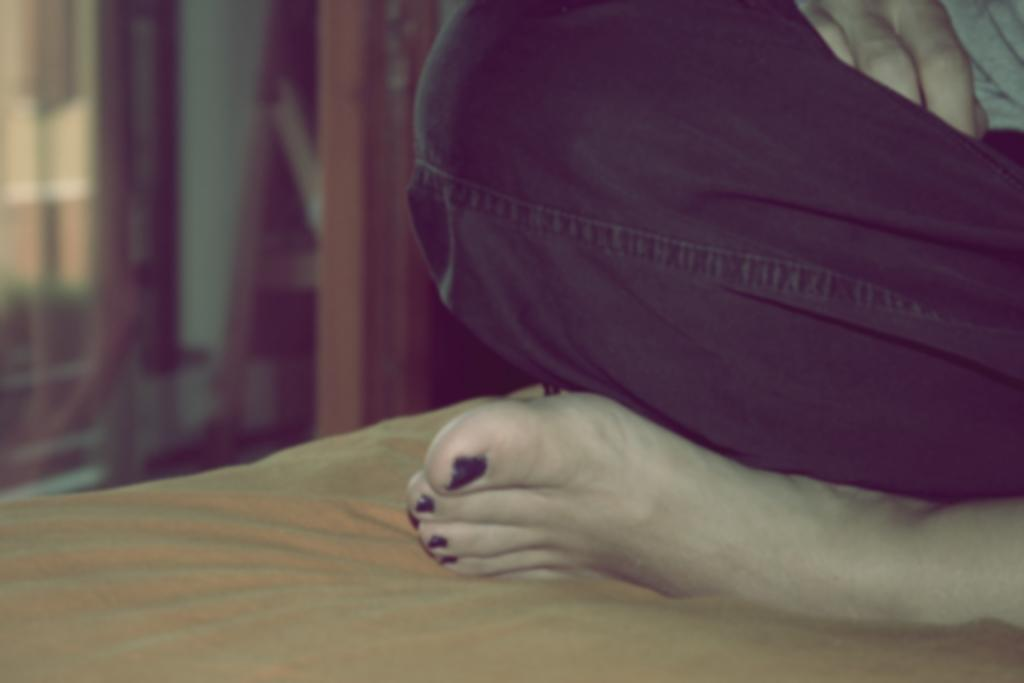What is located on the right side of the image? There is a person on the right side of the image. What type of clothing is the person wearing? The person is wearing pants. What is the person doing in the image? The person is sitting on an object. What is covering the object the person is sitting on? The object is covered with a cloth. How would you describe the background of the image? The background of the image is blurred. What type of band is playing in the background of the image? There is no band present in the image; the background is blurred. Can you see any tanks in the image? There are no tanks present in the image. 